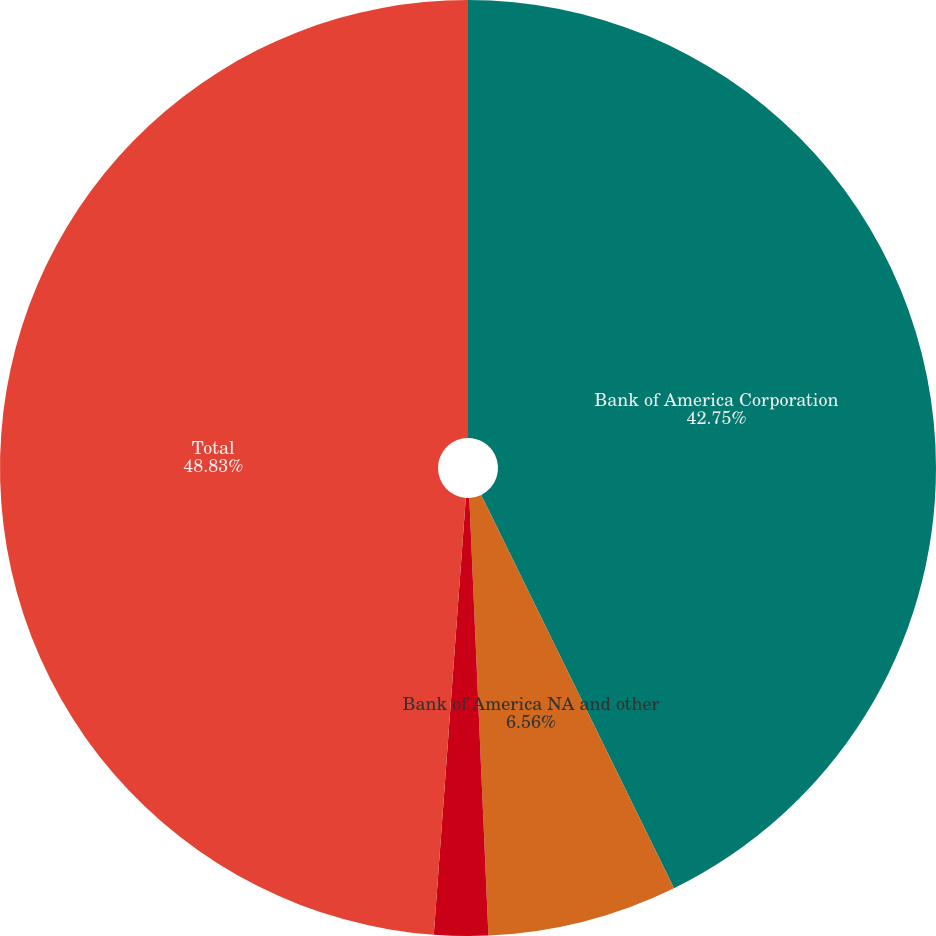Convert chart. <chart><loc_0><loc_0><loc_500><loc_500><pie_chart><fcel>Bank of America Corporation<fcel>Bank of America NA and other<fcel>Other<fcel>Total<nl><fcel>42.75%<fcel>6.56%<fcel>1.86%<fcel>48.84%<nl></chart> 